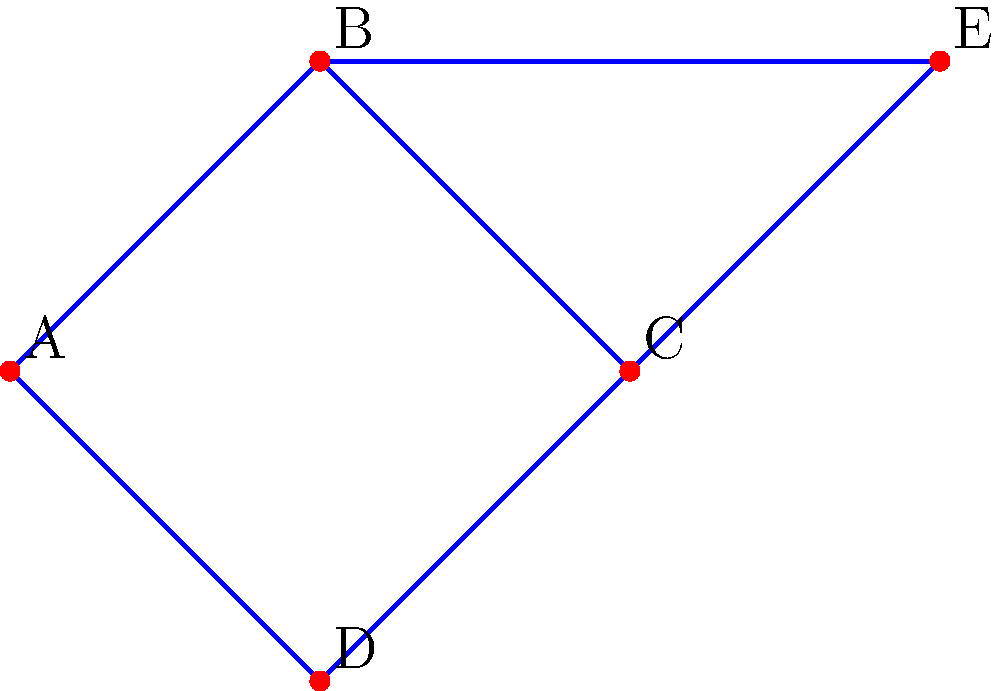Given the graph representing connections between educational resources, where vertices represent resources and edge weights represent the strength of connection, determine the minimum spanning tree. What is the total weight of the minimum spanning tree? To find the minimum spanning tree (MST), we'll use Kruskal's algorithm:

1. Sort all edges by weight in ascending order:
   (C,E): 2
   (A,D): 3
   (B,C): 4
   (A,B): 5
   (C,D): 6
   (B,E): 7
   (D,E): 8

2. Start with an empty MST and add edges that don't create cycles:
   - Add (C,E): 2
   - Add (A,D): 3
   - Add (B,C): 4
   - Add (A,B): 5

3. The MST is complete as we've included all vertices without creating cycles.

4. Calculate the total weight:
   $2 + 3 + 4 + 5 = 14$

Therefore, the minimum spanning tree has a total weight of 14.
Answer: 14 